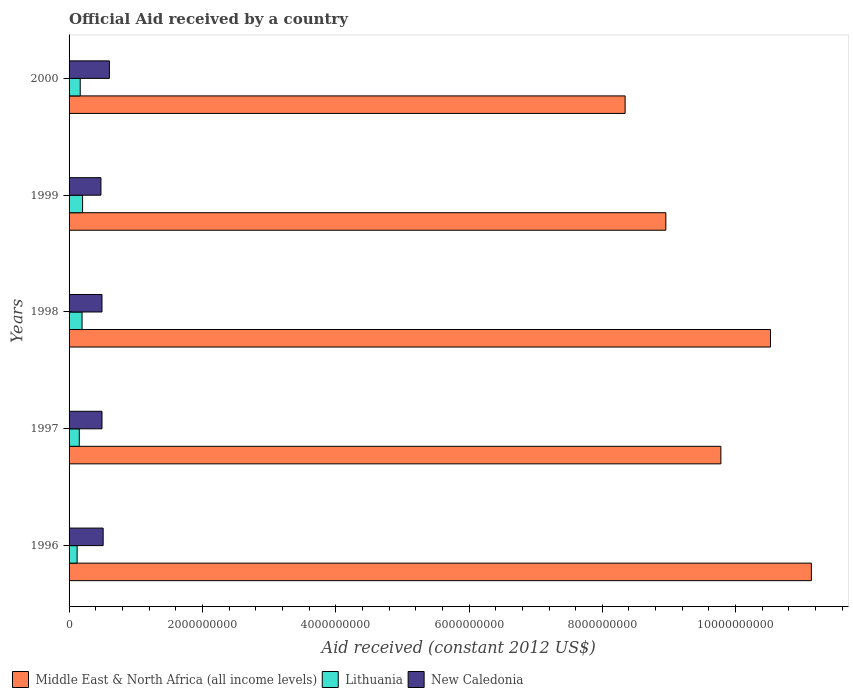How many different coloured bars are there?
Provide a succinct answer. 3. Are the number of bars per tick equal to the number of legend labels?
Your response must be concise. Yes. How many bars are there on the 2nd tick from the top?
Keep it short and to the point. 3. What is the net official aid received in Middle East & North Africa (all income levels) in 1997?
Provide a succinct answer. 9.78e+09. Across all years, what is the maximum net official aid received in Middle East & North Africa (all income levels)?
Your answer should be compact. 1.11e+1. Across all years, what is the minimum net official aid received in Middle East & North Africa (all income levels)?
Offer a terse response. 8.34e+09. In which year was the net official aid received in Middle East & North Africa (all income levels) minimum?
Provide a succinct answer. 2000. What is the total net official aid received in New Caledonia in the graph?
Keep it short and to the point. 2.58e+09. What is the difference between the net official aid received in New Caledonia in 1996 and that in 1998?
Make the answer very short. 1.74e+07. What is the difference between the net official aid received in Lithuania in 1996 and the net official aid received in Middle East & North Africa (all income levels) in 2000?
Keep it short and to the point. -8.22e+09. What is the average net official aid received in Lithuania per year?
Ensure brevity in your answer.  1.68e+08. In the year 1996, what is the difference between the net official aid received in Middle East & North Africa (all income levels) and net official aid received in New Caledonia?
Make the answer very short. 1.06e+1. What is the ratio of the net official aid received in New Caledonia in 1999 to that in 2000?
Make the answer very short. 0.79. Is the net official aid received in Lithuania in 1997 less than that in 1998?
Give a very brief answer. Yes. What is the difference between the highest and the second highest net official aid received in Lithuania?
Offer a very short reply. 8.09e+06. What is the difference between the highest and the lowest net official aid received in Middle East & North Africa (all income levels)?
Ensure brevity in your answer.  2.79e+09. In how many years, is the net official aid received in Middle East & North Africa (all income levels) greater than the average net official aid received in Middle East & North Africa (all income levels) taken over all years?
Your response must be concise. 3. Is the sum of the net official aid received in Lithuania in 1997 and 2000 greater than the maximum net official aid received in Middle East & North Africa (all income levels) across all years?
Your response must be concise. No. What does the 1st bar from the top in 1997 represents?
Offer a very short reply. New Caledonia. What does the 3rd bar from the bottom in 1996 represents?
Your answer should be compact. New Caledonia. Is it the case that in every year, the sum of the net official aid received in New Caledonia and net official aid received in Lithuania is greater than the net official aid received in Middle East & North Africa (all income levels)?
Your response must be concise. No. Are all the bars in the graph horizontal?
Make the answer very short. Yes. How many years are there in the graph?
Your answer should be very brief. 5. Does the graph contain grids?
Provide a short and direct response. No. Where does the legend appear in the graph?
Make the answer very short. Bottom left. How many legend labels are there?
Provide a succinct answer. 3. How are the legend labels stacked?
Your response must be concise. Horizontal. What is the title of the graph?
Ensure brevity in your answer.  Official Aid received by a country. What is the label or title of the X-axis?
Your answer should be compact. Aid received (constant 2012 US$). What is the Aid received (constant 2012 US$) of Middle East & North Africa (all income levels) in 1996?
Your answer should be very brief. 1.11e+1. What is the Aid received (constant 2012 US$) in Lithuania in 1996?
Give a very brief answer. 1.21e+08. What is the Aid received (constant 2012 US$) of New Caledonia in 1996?
Make the answer very short. 5.11e+08. What is the Aid received (constant 2012 US$) in Middle East & North Africa (all income levels) in 1997?
Offer a terse response. 9.78e+09. What is the Aid received (constant 2012 US$) in Lithuania in 1997?
Your answer should be compact. 1.53e+08. What is the Aid received (constant 2012 US$) of New Caledonia in 1997?
Your answer should be compact. 4.94e+08. What is the Aid received (constant 2012 US$) of Middle East & North Africa (all income levels) in 1998?
Make the answer very short. 1.05e+1. What is the Aid received (constant 2012 US$) in Lithuania in 1998?
Your answer should be compact. 1.95e+08. What is the Aid received (constant 2012 US$) in New Caledonia in 1998?
Your answer should be very brief. 4.94e+08. What is the Aid received (constant 2012 US$) of Middle East & North Africa (all income levels) in 1999?
Offer a terse response. 8.95e+09. What is the Aid received (constant 2012 US$) of Lithuania in 1999?
Your response must be concise. 2.03e+08. What is the Aid received (constant 2012 US$) of New Caledonia in 1999?
Your answer should be compact. 4.78e+08. What is the Aid received (constant 2012 US$) of Middle East & North Africa (all income levels) in 2000?
Offer a very short reply. 8.34e+09. What is the Aid received (constant 2012 US$) in Lithuania in 2000?
Provide a succinct answer. 1.67e+08. What is the Aid received (constant 2012 US$) of New Caledonia in 2000?
Make the answer very short. 6.05e+08. Across all years, what is the maximum Aid received (constant 2012 US$) in Middle East & North Africa (all income levels)?
Provide a succinct answer. 1.11e+1. Across all years, what is the maximum Aid received (constant 2012 US$) in Lithuania?
Offer a very short reply. 2.03e+08. Across all years, what is the maximum Aid received (constant 2012 US$) of New Caledonia?
Offer a terse response. 6.05e+08. Across all years, what is the minimum Aid received (constant 2012 US$) in Middle East & North Africa (all income levels)?
Make the answer very short. 8.34e+09. Across all years, what is the minimum Aid received (constant 2012 US$) in Lithuania?
Offer a very short reply. 1.21e+08. Across all years, what is the minimum Aid received (constant 2012 US$) in New Caledonia?
Make the answer very short. 4.78e+08. What is the total Aid received (constant 2012 US$) in Middle East & North Africa (all income levels) in the graph?
Offer a very short reply. 4.87e+1. What is the total Aid received (constant 2012 US$) in Lithuania in the graph?
Your answer should be very brief. 8.39e+08. What is the total Aid received (constant 2012 US$) in New Caledonia in the graph?
Provide a short and direct response. 2.58e+09. What is the difference between the Aid received (constant 2012 US$) in Middle East & North Africa (all income levels) in 1996 and that in 1997?
Your response must be concise. 1.36e+09. What is the difference between the Aid received (constant 2012 US$) in Lithuania in 1996 and that in 1997?
Offer a very short reply. -3.27e+07. What is the difference between the Aid received (constant 2012 US$) in New Caledonia in 1996 and that in 1997?
Your answer should be compact. 1.72e+07. What is the difference between the Aid received (constant 2012 US$) of Middle East & North Africa (all income levels) in 1996 and that in 1998?
Provide a short and direct response. 6.14e+08. What is the difference between the Aid received (constant 2012 US$) of Lithuania in 1996 and that in 1998?
Offer a terse response. -7.41e+07. What is the difference between the Aid received (constant 2012 US$) in New Caledonia in 1996 and that in 1998?
Make the answer very short. 1.74e+07. What is the difference between the Aid received (constant 2012 US$) in Middle East & North Africa (all income levels) in 1996 and that in 1999?
Your answer should be very brief. 2.18e+09. What is the difference between the Aid received (constant 2012 US$) of Lithuania in 1996 and that in 1999?
Give a very brief answer. -8.22e+07. What is the difference between the Aid received (constant 2012 US$) in New Caledonia in 1996 and that in 1999?
Make the answer very short. 3.32e+07. What is the difference between the Aid received (constant 2012 US$) of Middle East & North Africa (all income levels) in 1996 and that in 2000?
Offer a very short reply. 2.79e+09. What is the difference between the Aid received (constant 2012 US$) in Lithuania in 1996 and that in 2000?
Your answer should be very brief. -4.65e+07. What is the difference between the Aid received (constant 2012 US$) in New Caledonia in 1996 and that in 2000?
Offer a terse response. -9.35e+07. What is the difference between the Aid received (constant 2012 US$) of Middle East & North Africa (all income levels) in 1997 and that in 1998?
Your answer should be very brief. -7.44e+08. What is the difference between the Aid received (constant 2012 US$) of Lithuania in 1997 and that in 1998?
Ensure brevity in your answer.  -4.14e+07. What is the difference between the Aid received (constant 2012 US$) of Middle East & North Africa (all income levels) in 1997 and that in 1999?
Provide a succinct answer. 8.26e+08. What is the difference between the Aid received (constant 2012 US$) in Lithuania in 1997 and that in 1999?
Provide a succinct answer. -4.95e+07. What is the difference between the Aid received (constant 2012 US$) of New Caledonia in 1997 and that in 1999?
Offer a very short reply. 1.61e+07. What is the difference between the Aid received (constant 2012 US$) of Middle East & North Africa (all income levels) in 1997 and that in 2000?
Offer a terse response. 1.44e+09. What is the difference between the Aid received (constant 2012 US$) in Lithuania in 1997 and that in 2000?
Your answer should be very brief. -1.38e+07. What is the difference between the Aid received (constant 2012 US$) of New Caledonia in 1997 and that in 2000?
Your answer should be very brief. -1.11e+08. What is the difference between the Aid received (constant 2012 US$) of Middle East & North Africa (all income levels) in 1998 and that in 1999?
Make the answer very short. 1.57e+09. What is the difference between the Aid received (constant 2012 US$) of Lithuania in 1998 and that in 1999?
Provide a succinct answer. -8.09e+06. What is the difference between the Aid received (constant 2012 US$) in New Caledonia in 1998 and that in 1999?
Give a very brief answer. 1.58e+07. What is the difference between the Aid received (constant 2012 US$) in Middle East & North Africa (all income levels) in 1998 and that in 2000?
Offer a very short reply. 2.18e+09. What is the difference between the Aid received (constant 2012 US$) in Lithuania in 1998 and that in 2000?
Your response must be concise. 2.76e+07. What is the difference between the Aid received (constant 2012 US$) in New Caledonia in 1998 and that in 2000?
Provide a succinct answer. -1.11e+08. What is the difference between the Aid received (constant 2012 US$) in Middle East & North Africa (all income levels) in 1999 and that in 2000?
Provide a short and direct response. 6.11e+08. What is the difference between the Aid received (constant 2012 US$) of Lithuania in 1999 and that in 2000?
Offer a terse response. 3.57e+07. What is the difference between the Aid received (constant 2012 US$) in New Caledonia in 1999 and that in 2000?
Keep it short and to the point. -1.27e+08. What is the difference between the Aid received (constant 2012 US$) of Middle East & North Africa (all income levels) in 1996 and the Aid received (constant 2012 US$) of Lithuania in 1997?
Your answer should be compact. 1.10e+1. What is the difference between the Aid received (constant 2012 US$) in Middle East & North Africa (all income levels) in 1996 and the Aid received (constant 2012 US$) in New Caledonia in 1997?
Ensure brevity in your answer.  1.06e+1. What is the difference between the Aid received (constant 2012 US$) of Lithuania in 1996 and the Aid received (constant 2012 US$) of New Caledonia in 1997?
Offer a very short reply. -3.73e+08. What is the difference between the Aid received (constant 2012 US$) of Middle East & North Africa (all income levels) in 1996 and the Aid received (constant 2012 US$) of Lithuania in 1998?
Your answer should be compact. 1.09e+1. What is the difference between the Aid received (constant 2012 US$) of Middle East & North Africa (all income levels) in 1996 and the Aid received (constant 2012 US$) of New Caledonia in 1998?
Give a very brief answer. 1.06e+1. What is the difference between the Aid received (constant 2012 US$) of Lithuania in 1996 and the Aid received (constant 2012 US$) of New Caledonia in 1998?
Your answer should be very brief. -3.73e+08. What is the difference between the Aid received (constant 2012 US$) of Middle East & North Africa (all income levels) in 1996 and the Aid received (constant 2012 US$) of Lithuania in 1999?
Provide a short and direct response. 1.09e+1. What is the difference between the Aid received (constant 2012 US$) of Middle East & North Africa (all income levels) in 1996 and the Aid received (constant 2012 US$) of New Caledonia in 1999?
Provide a short and direct response. 1.07e+1. What is the difference between the Aid received (constant 2012 US$) of Lithuania in 1996 and the Aid received (constant 2012 US$) of New Caledonia in 1999?
Offer a very short reply. -3.57e+08. What is the difference between the Aid received (constant 2012 US$) in Middle East & North Africa (all income levels) in 1996 and the Aid received (constant 2012 US$) in Lithuania in 2000?
Your response must be concise. 1.10e+1. What is the difference between the Aid received (constant 2012 US$) of Middle East & North Africa (all income levels) in 1996 and the Aid received (constant 2012 US$) of New Caledonia in 2000?
Keep it short and to the point. 1.05e+1. What is the difference between the Aid received (constant 2012 US$) of Lithuania in 1996 and the Aid received (constant 2012 US$) of New Caledonia in 2000?
Make the answer very short. -4.84e+08. What is the difference between the Aid received (constant 2012 US$) of Middle East & North Africa (all income levels) in 1997 and the Aid received (constant 2012 US$) of Lithuania in 1998?
Give a very brief answer. 9.58e+09. What is the difference between the Aid received (constant 2012 US$) in Middle East & North Africa (all income levels) in 1997 and the Aid received (constant 2012 US$) in New Caledonia in 1998?
Give a very brief answer. 9.28e+09. What is the difference between the Aid received (constant 2012 US$) in Lithuania in 1997 and the Aid received (constant 2012 US$) in New Caledonia in 1998?
Provide a short and direct response. -3.40e+08. What is the difference between the Aid received (constant 2012 US$) in Middle East & North Africa (all income levels) in 1997 and the Aid received (constant 2012 US$) in Lithuania in 1999?
Provide a short and direct response. 9.58e+09. What is the difference between the Aid received (constant 2012 US$) of Middle East & North Africa (all income levels) in 1997 and the Aid received (constant 2012 US$) of New Caledonia in 1999?
Give a very brief answer. 9.30e+09. What is the difference between the Aid received (constant 2012 US$) in Lithuania in 1997 and the Aid received (constant 2012 US$) in New Caledonia in 1999?
Your response must be concise. -3.25e+08. What is the difference between the Aid received (constant 2012 US$) in Middle East & North Africa (all income levels) in 1997 and the Aid received (constant 2012 US$) in Lithuania in 2000?
Your response must be concise. 9.61e+09. What is the difference between the Aid received (constant 2012 US$) in Middle East & North Africa (all income levels) in 1997 and the Aid received (constant 2012 US$) in New Caledonia in 2000?
Your answer should be compact. 9.17e+09. What is the difference between the Aid received (constant 2012 US$) of Lithuania in 1997 and the Aid received (constant 2012 US$) of New Caledonia in 2000?
Keep it short and to the point. -4.51e+08. What is the difference between the Aid received (constant 2012 US$) of Middle East & North Africa (all income levels) in 1998 and the Aid received (constant 2012 US$) of Lithuania in 1999?
Your response must be concise. 1.03e+1. What is the difference between the Aid received (constant 2012 US$) of Middle East & North Africa (all income levels) in 1998 and the Aid received (constant 2012 US$) of New Caledonia in 1999?
Offer a terse response. 1.00e+1. What is the difference between the Aid received (constant 2012 US$) of Lithuania in 1998 and the Aid received (constant 2012 US$) of New Caledonia in 1999?
Provide a short and direct response. -2.83e+08. What is the difference between the Aid received (constant 2012 US$) in Middle East & North Africa (all income levels) in 1998 and the Aid received (constant 2012 US$) in Lithuania in 2000?
Provide a succinct answer. 1.04e+1. What is the difference between the Aid received (constant 2012 US$) of Middle East & North Africa (all income levels) in 1998 and the Aid received (constant 2012 US$) of New Caledonia in 2000?
Your response must be concise. 9.92e+09. What is the difference between the Aid received (constant 2012 US$) of Lithuania in 1998 and the Aid received (constant 2012 US$) of New Caledonia in 2000?
Ensure brevity in your answer.  -4.10e+08. What is the difference between the Aid received (constant 2012 US$) in Middle East & North Africa (all income levels) in 1999 and the Aid received (constant 2012 US$) in Lithuania in 2000?
Your response must be concise. 8.79e+09. What is the difference between the Aid received (constant 2012 US$) in Middle East & North Africa (all income levels) in 1999 and the Aid received (constant 2012 US$) in New Caledonia in 2000?
Keep it short and to the point. 8.35e+09. What is the difference between the Aid received (constant 2012 US$) in Lithuania in 1999 and the Aid received (constant 2012 US$) in New Caledonia in 2000?
Give a very brief answer. -4.02e+08. What is the average Aid received (constant 2012 US$) in Middle East & North Africa (all income levels) per year?
Make the answer very short. 9.75e+09. What is the average Aid received (constant 2012 US$) in Lithuania per year?
Offer a terse response. 1.68e+08. What is the average Aid received (constant 2012 US$) in New Caledonia per year?
Provide a succinct answer. 5.16e+08. In the year 1996, what is the difference between the Aid received (constant 2012 US$) in Middle East & North Africa (all income levels) and Aid received (constant 2012 US$) in Lithuania?
Ensure brevity in your answer.  1.10e+1. In the year 1996, what is the difference between the Aid received (constant 2012 US$) in Middle East & North Africa (all income levels) and Aid received (constant 2012 US$) in New Caledonia?
Your answer should be very brief. 1.06e+1. In the year 1996, what is the difference between the Aid received (constant 2012 US$) of Lithuania and Aid received (constant 2012 US$) of New Caledonia?
Give a very brief answer. -3.90e+08. In the year 1997, what is the difference between the Aid received (constant 2012 US$) of Middle East & North Africa (all income levels) and Aid received (constant 2012 US$) of Lithuania?
Your answer should be very brief. 9.63e+09. In the year 1997, what is the difference between the Aid received (constant 2012 US$) of Middle East & North Africa (all income levels) and Aid received (constant 2012 US$) of New Caledonia?
Offer a very short reply. 9.28e+09. In the year 1997, what is the difference between the Aid received (constant 2012 US$) in Lithuania and Aid received (constant 2012 US$) in New Caledonia?
Your answer should be compact. -3.41e+08. In the year 1998, what is the difference between the Aid received (constant 2012 US$) of Middle East & North Africa (all income levels) and Aid received (constant 2012 US$) of Lithuania?
Your answer should be very brief. 1.03e+1. In the year 1998, what is the difference between the Aid received (constant 2012 US$) in Middle East & North Africa (all income levels) and Aid received (constant 2012 US$) in New Caledonia?
Give a very brief answer. 1.00e+1. In the year 1998, what is the difference between the Aid received (constant 2012 US$) of Lithuania and Aid received (constant 2012 US$) of New Caledonia?
Offer a terse response. -2.99e+08. In the year 1999, what is the difference between the Aid received (constant 2012 US$) in Middle East & North Africa (all income levels) and Aid received (constant 2012 US$) in Lithuania?
Offer a terse response. 8.75e+09. In the year 1999, what is the difference between the Aid received (constant 2012 US$) of Middle East & North Africa (all income levels) and Aid received (constant 2012 US$) of New Caledonia?
Provide a succinct answer. 8.47e+09. In the year 1999, what is the difference between the Aid received (constant 2012 US$) in Lithuania and Aid received (constant 2012 US$) in New Caledonia?
Your response must be concise. -2.75e+08. In the year 2000, what is the difference between the Aid received (constant 2012 US$) of Middle East & North Africa (all income levels) and Aid received (constant 2012 US$) of Lithuania?
Ensure brevity in your answer.  8.17e+09. In the year 2000, what is the difference between the Aid received (constant 2012 US$) in Middle East & North Africa (all income levels) and Aid received (constant 2012 US$) in New Caledonia?
Your answer should be compact. 7.74e+09. In the year 2000, what is the difference between the Aid received (constant 2012 US$) of Lithuania and Aid received (constant 2012 US$) of New Caledonia?
Provide a succinct answer. -4.38e+08. What is the ratio of the Aid received (constant 2012 US$) in Middle East & North Africa (all income levels) in 1996 to that in 1997?
Your response must be concise. 1.14. What is the ratio of the Aid received (constant 2012 US$) in Lithuania in 1996 to that in 1997?
Your answer should be very brief. 0.79. What is the ratio of the Aid received (constant 2012 US$) of New Caledonia in 1996 to that in 1997?
Provide a succinct answer. 1.03. What is the ratio of the Aid received (constant 2012 US$) of Middle East & North Africa (all income levels) in 1996 to that in 1998?
Provide a succinct answer. 1.06. What is the ratio of the Aid received (constant 2012 US$) of Lithuania in 1996 to that in 1998?
Keep it short and to the point. 0.62. What is the ratio of the Aid received (constant 2012 US$) of New Caledonia in 1996 to that in 1998?
Give a very brief answer. 1.04. What is the ratio of the Aid received (constant 2012 US$) of Middle East & North Africa (all income levels) in 1996 to that in 1999?
Make the answer very short. 1.24. What is the ratio of the Aid received (constant 2012 US$) in Lithuania in 1996 to that in 1999?
Your answer should be very brief. 0.6. What is the ratio of the Aid received (constant 2012 US$) of New Caledonia in 1996 to that in 1999?
Give a very brief answer. 1.07. What is the ratio of the Aid received (constant 2012 US$) of Middle East & North Africa (all income levels) in 1996 to that in 2000?
Make the answer very short. 1.33. What is the ratio of the Aid received (constant 2012 US$) in Lithuania in 1996 to that in 2000?
Make the answer very short. 0.72. What is the ratio of the Aid received (constant 2012 US$) in New Caledonia in 1996 to that in 2000?
Keep it short and to the point. 0.85. What is the ratio of the Aid received (constant 2012 US$) of Middle East & North Africa (all income levels) in 1997 to that in 1998?
Give a very brief answer. 0.93. What is the ratio of the Aid received (constant 2012 US$) in Lithuania in 1997 to that in 1998?
Give a very brief answer. 0.79. What is the ratio of the Aid received (constant 2012 US$) of Middle East & North Africa (all income levels) in 1997 to that in 1999?
Your response must be concise. 1.09. What is the ratio of the Aid received (constant 2012 US$) in Lithuania in 1997 to that in 1999?
Ensure brevity in your answer.  0.76. What is the ratio of the Aid received (constant 2012 US$) in New Caledonia in 1997 to that in 1999?
Keep it short and to the point. 1.03. What is the ratio of the Aid received (constant 2012 US$) of Middle East & North Africa (all income levels) in 1997 to that in 2000?
Your answer should be very brief. 1.17. What is the ratio of the Aid received (constant 2012 US$) in Lithuania in 1997 to that in 2000?
Ensure brevity in your answer.  0.92. What is the ratio of the Aid received (constant 2012 US$) of New Caledonia in 1997 to that in 2000?
Offer a terse response. 0.82. What is the ratio of the Aid received (constant 2012 US$) of Middle East & North Africa (all income levels) in 1998 to that in 1999?
Provide a short and direct response. 1.18. What is the ratio of the Aid received (constant 2012 US$) in Lithuania in 1998 to that in 1999?
Keep it short and to the point. 0.96. What is the ratio of the Aid received (constant 2012 US$) in New Caledonia in 1998 to that in 1999?
Keep it short and to the point. 1.03. What is the ratio of the Aid received (constant 2012 US$) of Middle East & North Africa (all income levels) in 1998 to that in 2000?
Offer a terse response. 1.26. What is the ratio of the Aid received (constant 2012 US$) of Lithuania in 1998 to that in 2000?
Your answer should be compact. 1.16. What is the ratio of the Aid received (constant 2012 US$) in New Caledonia in 1998 to that in 2000?
Provide a short and direct response. 0.82. What is the ratio of the Aid received (constant 2012 US$) of Middle East & North Africa (all income levels) in 1999 to that in 2000?
Make the answer very short. 1.07. What is the ratio of the Aid received (constant 2012 US$) of Lithuania in 1999 to that in 2000?
Make the answer very short. 1.21. What is the ratio of the Aid received (constant 2012 US$) of New Caledonia in 1999 to that in 2000?
Provide a succinct answer. 0.79. What is the difference between the highest and the second highest Aid received (constant 2012 US$) of Middle East & North Africa (all income levels)?
Your answer should be compact. 6.14e+08. What is the difference between the highest and the second highest Aid received (constant 2012 US$) of Lithuania?
Give a very brief answer. 8.09e+06. What is the difference between the highest and the second highest Aid received (constant 2012 US$) of New Caledonia?
Your answer should be compact. 9.35e+07. What is the difference between the highest and the lowest Aid received (constant 2012 US$) of Middle East & North Africa (all income levels)?
Your response must be concise. 2.79e+09. What is the difference between the highest and the lowest Aid received (constant 2012 US$) of Lithuania?
Offer a very short reply. 8.22e+07. What is the difference between the highest and the lowest Aid received (constant 2012 US$) of New Caledonia?
Ensure brevity in your answer.  1.27e+08. 